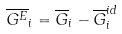<formula> <loc_0><loc_0><loc_500><loc_500>\overline { G ^ { E } } _ { i } = \overline { G } _ { i } - \overline { G } _ { i } ^ { i d }</formula> 